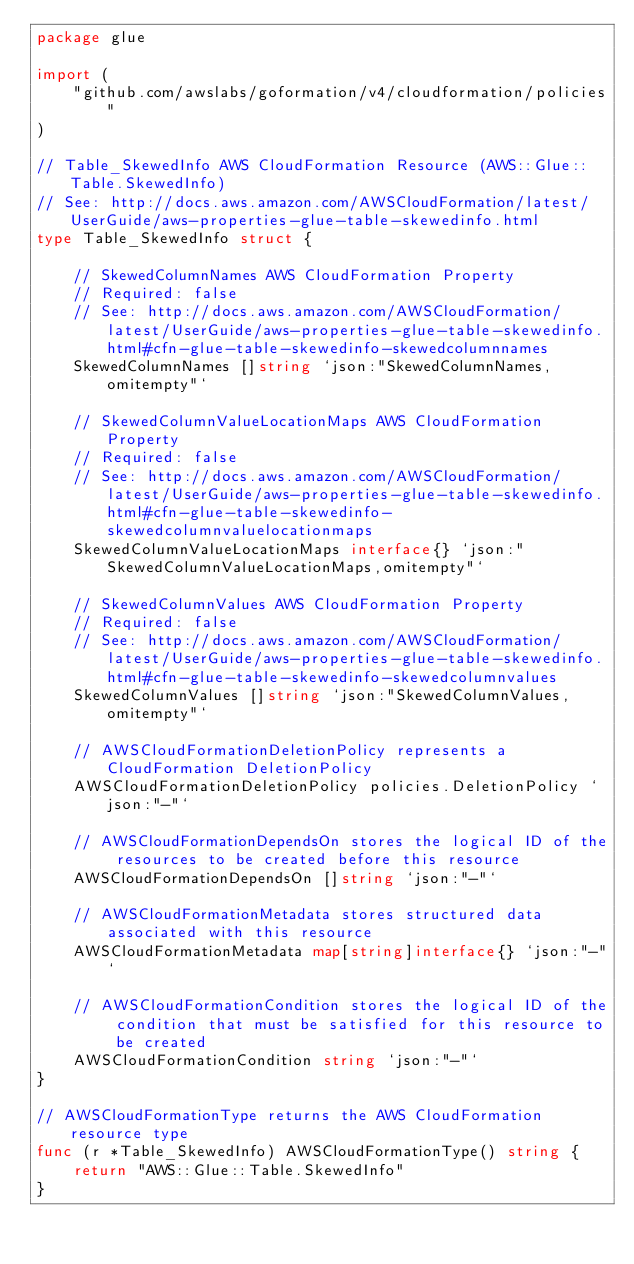<code> <loc_0><loc_0><loc_500><loc_500><_Go_>package glue

import (
	"github.com/awslabs/goformation/v4/cloudformation/policies"
)

// Table_SkewedInfo AWS CloudFormation Resource (AWS::Glue::Table.SkewedInfo)
// See: http://docs.aws.amazon.com/AWSCloudFormation/latest/UserGuide/aws-properties-glue-table-skewedinfo.html
type Table_SkewedInfo struct {

	// SkewedColumnNames AWS CloudFormation Property
	// Required: false
	// See: http://docs.aws.amazon.com/AWSCloudFormation/latest/UserGuide/aws-properties-glue-table-skewedinfo.html#cfn-glue-table-skewedinfo-skewedcolumnnames
	SkewedColumnNames []string `json:"SkewedColumnNames,omitempty"`

	// SkewedColumnValueLocationMaps AWS CloudFormation Property
	// Required: false
	// See: http://docs.aws.amazon.com/AWSCloudFormation/latest/UserGuide/aws-properties-glue-table-skewedinfo.html#cfn-glue-table-skewedinfo-skewedcolumnvaluelocationmaps
	SkewedColumnValueLocationMaps interface{} `json:"SkewedColumnValueLocationMaps,omitempty"`

	// SkewedColumnValues AWS CloudFormation Property
	// Required: false
	// See: http://docs.aws.amazon.com/AWSCloudFormation/latest/UserGuide/aws-properties-glue-table-skewedinfo.html#cfn-glue-table-skewedinfo-skewedcolumnvalues
	SkewedColumnValues []string `json:"SkewedColumnValues,omitempty"`

	// AWSCloudFormationDeletionPolicy represents a CloudFormation DeletionPolicy
	AWSCloudFormationDeletionPolicy policies.DeletionPolicy `json:"-"`

	// AWSCloudFormationDependsOn stores the logical ID of the resources to be created before this resource
	AWSCloudFormationDependsOn []string `json:"-"`

	// AWSCloudFormationMetadata stores structured data associated with this resource
	AWSCloudFormationMetadata map[string]interface{} `json:"-"`

	// AWSCloudFormationCondition stores the logical ID of the condition that must be satisfied for this resource to be created
	AWSCloudFormationCondition string `json:"-"`
}

// AWSCloudFormationType returns the AWS CloudFormation resource type
func (r *Table_SkewedInfo) AWSCloudFormationType() string {
	return "AWS::Glue::Table.SkewedInfo"
}
</code> 